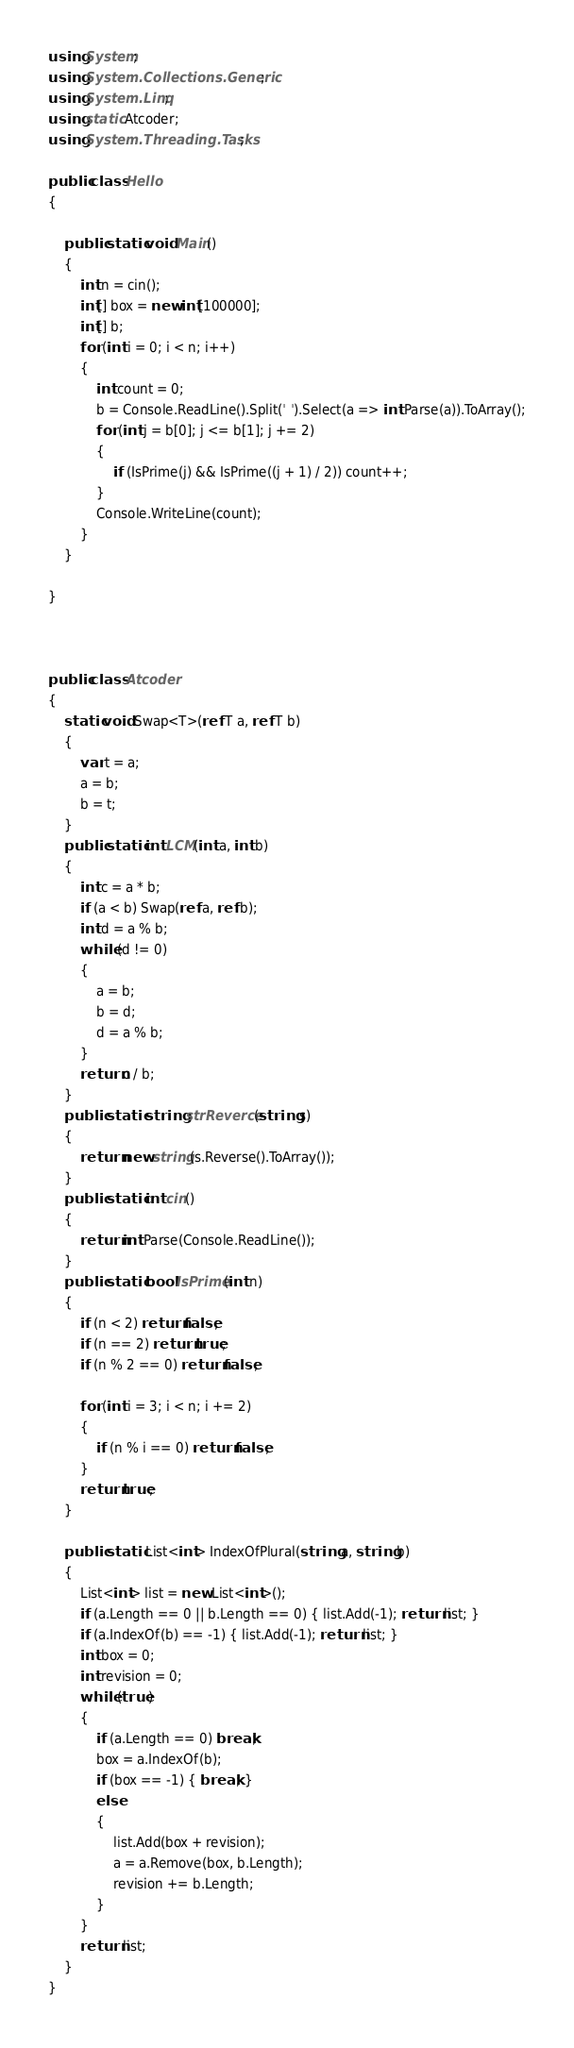<code> <loc_0><loc_0><loc_500><loc_500><_C#_>using System;
using System.Collections.Generic;
using System.Linq;
using static Atcoder;
using System.Threading.Tasks;

public class Hello
{

    public static void Main()
    {
        int n = cin();
        int[] box = new int[100000];
        int[] b;
        for (int i = 0; i < n; i++)
        {
            int count = 0;
            b = Console.ReadLine().Split(' ').Select(a => int.Parse(a)).ToArray();
            for (int j = b[0]; j <= b[1]; j += 2)
            {
                if (IsPrime(j) && IsPrime((j + 1) / 2)) count++;
            }
            Console.WriteLine(count);
        }
    }

}



public class Atcoder
{
    static void Swap<T>(ref T a, ref T b)
    {
        var t = a;
        a = b;
        b = t;
    }
    public static int LCM(int a, int b)
    {
        int c = a * b;
        if (a < b) Swap(ref a, ref b);
        int d = a % b;
        while (d != 0)
        {
            a = b;
            b = d;
            d = a % b;
        }
        return c / b;
    }
    public static string strReverce(string s)
    {
        return new string(s.Reverse().ToArray());
    }
    public static int cin()
    {
        return int.Parse(Console.ReadLine());
    }
    public static bool IsPrime(int n)
    {
        if (n < 2) return false;
        if (n == 2) return true;
        if (n % 2 == 0) return false;

        for (int i = 3; i < n; i += 2)
        {
            if (n % i == 0) return false;
        }
        return true;
    }

    public static List<int> IndexOfPlural(string a, string b)
    {
        List<int> list = new List<int>();
        if (a.Length == 0 || b.Length == 0) { list.Add(-1); return list; }
        if (a.IndexOf(b) == -1) { list.Add(-1); return list; }
        int box = 0;
        int revision = 0;
        while (true)
        {
            if (a.Length == 0) break;
            box = a.IndexOf(b);
            if (box == -1) { break; }
            else
            {
                list.Add(box + revision);
                a = a.Remove(box, b.Length);
                revision += b.Length;
            }
        }
        return list;
    }
}
</code> 